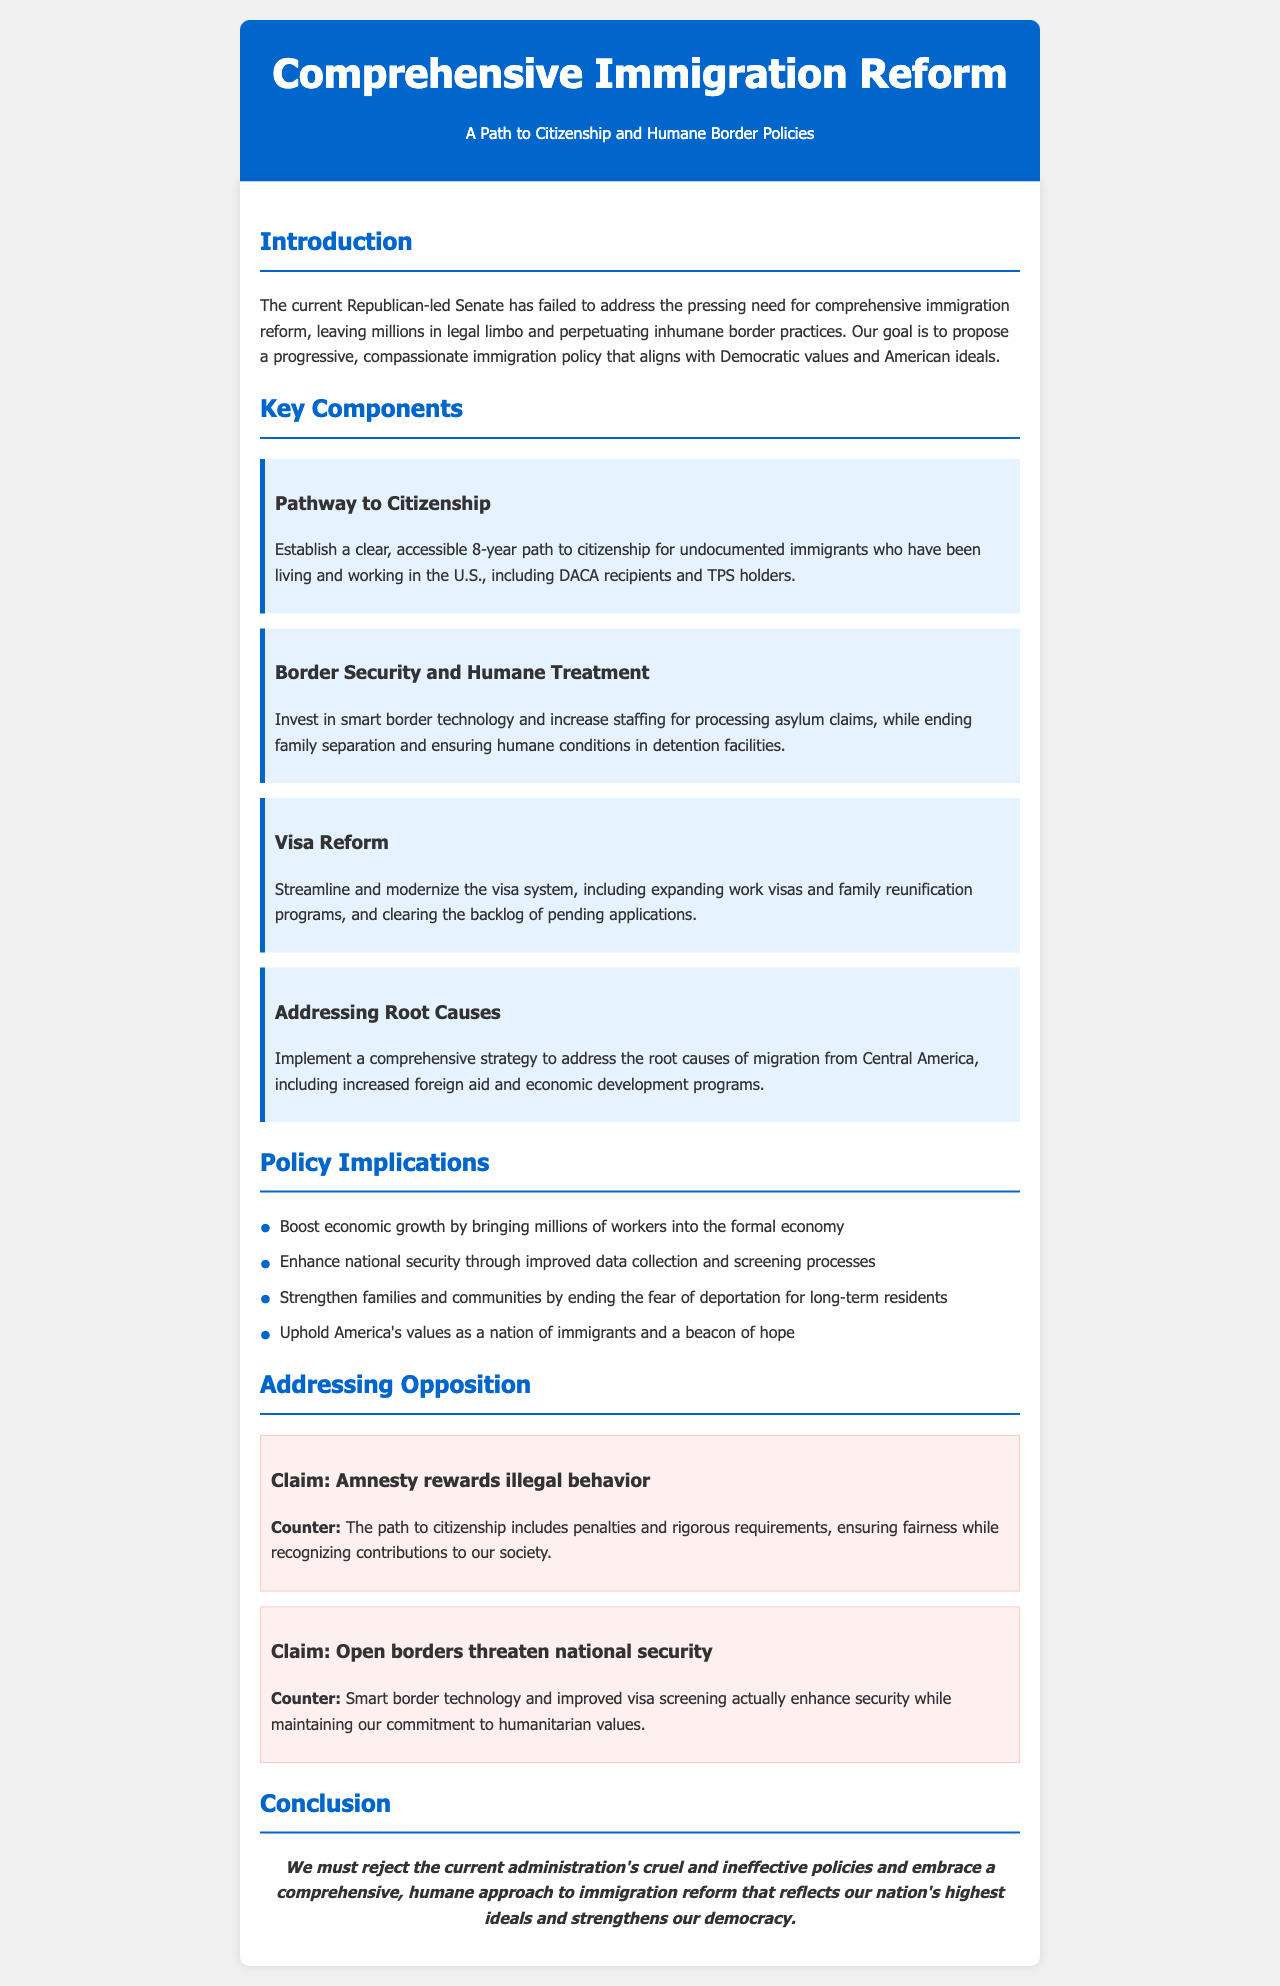What is the proposed path to citizenship duration for undocumented immigrants? The document states an "accessible 8-year path to citizenship" for undocumented immigrants.
Answer: 8 years What key component addresses humane treatment at the border? The section titled "Border Security and Humane Treatment" discusses investment in smart border technology and humane conditions.
Answer: Humane Treatment Which groups are included in the pathway to citizenship? The document mentions that the pathway includes "DACA recipients and TPS holders."
Answer: DACA recipients and TPS holders What economic impact is anticipated from the proposed reform? The document suggests that the reform will "boost economic growth by bringing millions of workers into the formal economy."
Answer: Boost economic growth What is one counterargument to the claim that amnesty rewards illegal behavior? The text highlights that "the path to citizenship includes penalties and rigorous requirements."
Answer: Penalties and rigorous requirements What approach is taken towards addressing the root causes of migration? The document proposes "increased foreign aid and economic development programs."
Answer: Increased foreign aid and economic development programs What is said about national security in relation to the new proposal? The document states that "smart border technology and improved visa screening enhance security."
Answer: Enhance security What is the stance of the document on current immigration policies? It expresses the need to "reject the current administration's cruel and ineffective policies."
Answer: Reject the current administration's policies 